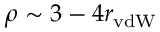Convert formula to latex. <formula><loc_0><loc_0><loc_500><loc_500>\rho \sim 3 - 4 r _ { v d W }</formula> 